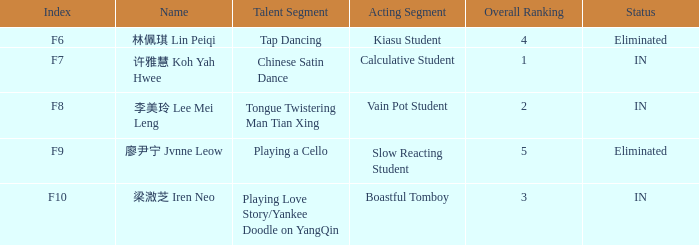Can you identify the talent segment in the event with index f9? Playing a Cello. 